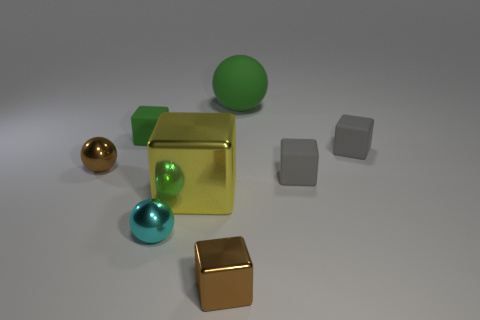Is there anything else that has the same color as the big shiny block?
Your answer should be very brief. No. The big matte ball that is right of the brown object that is right of the cyan shiny ball is what color?
Your answer should be very brief. Green. Are there any gray rubber objects?
Your answer should be very brief. Yes. What is the color of the metallic object that is right of the small cyan metallic object and behind the tiny cyan object?
Provide a short and direct response. Yellow. There is a shiny object behind the large metallic object; is it the same size as the metal ball that is in front of the yellow cube?
Make the answer very short. Yes. What number of other objects are there of the same size as the brown shiny ball?
Your answer should be compact. 5. There is a large yellow shiny thing to the left of the big green rubber object; what number of small brown shiny objects are in front of it?
Provide a short and direct response. 1. Are there fewer cyan shiny objects to the left of the tiny brown metallic ball than green blocks?
Your answer should be compact. Yes. What is the shape of the tiny brown shiny object that is in front of the brown ball that is behind the big thing to the left of the small brown metallic block?
Provide a short and direct response. Cube. Is the shape of the large rubber object the same as the yellow thing?
Your answer should be compact. No. 